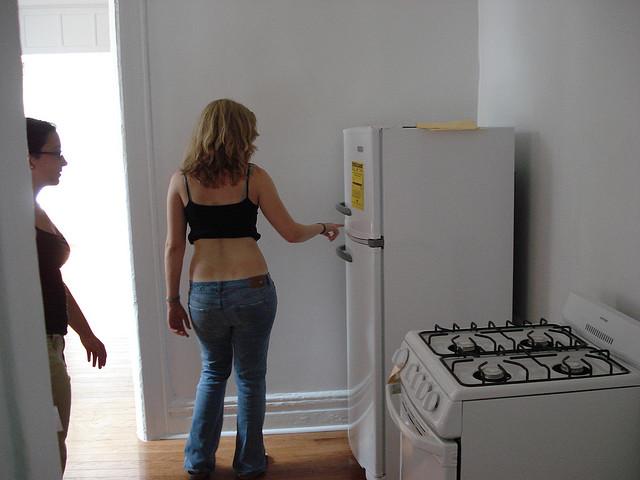What is in the woman's right hand?
Keep it brief. Nothing. Is that a real fridge?
Give a very brief answer. Yes. What room is this?
Give a very brief answer. Kitchen. Is that a real stove?
Short answer required. Yes. Does this woman have shoes on?
Keep it brief. Yes. Is the woman's hair very short?
Keep it brief. No. IS she wearing pants?
Short answer required. Yes. What color is the refrigerator?
Be succinct. White. What is reflecting on the refrigerator door?
Write a very short answer. Light. What color is the woman's shirt?
Give a very brief answer. Black. What is the woman opening?
Concise answer only. Fridge. How many women are there?
Write a very short answer. 2. Is the woman appropriately clothed?
Answer briefly. No. What is on top of the fridge?
Give a very brief answer. Paper. What color is the fridge?
Keep it brief. White. Is there a factory sticker on the appliances?
Write a very short answer. Yes. 